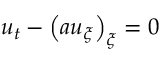Convert formula to latex. <formula><loc_0><loc_0><loc_500><loc_500>\begin{array} { r } { u _ { t } - \left ( a u _ { \xi } \right ) _ { \xi } = 0 } \end{array}</formula> 